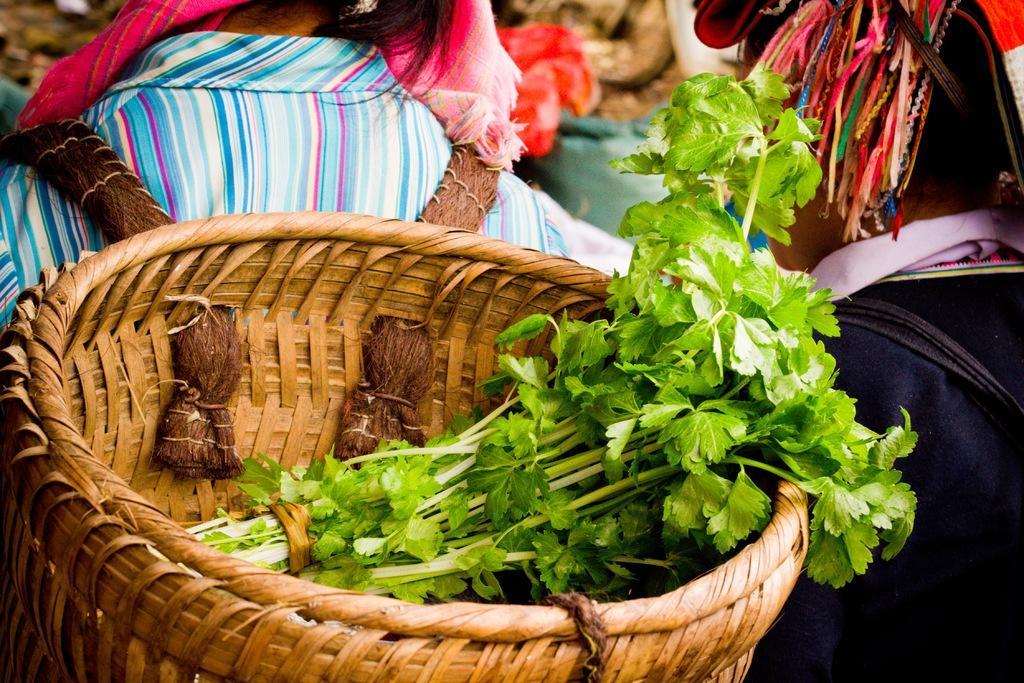Could you give a brief overview of what you see in this image? In the image there are coriander leaves in a basket and the basket is worn by a person. On the right side there is another person. 